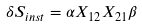Convert formula to latex. <formula><loc_0><loc_0><loc_500><loc_500>\delta S _ { i n s t } = \alpha X _ { 1 2 } X _ { 2 1 } \beta</formula> 